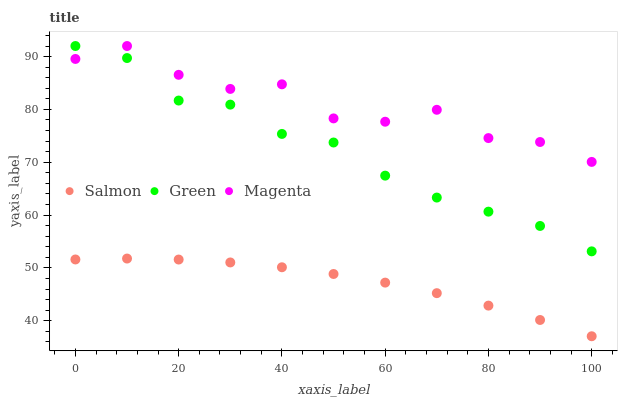Does Salmon have the minimum area under the curve?
Answer yes or no. Yes. Does Magenta have the maximum area under the curve?
Answer yes or no. Yes. Does Magenta have the minimum area under the curve?
Answer yes or no. No. Does Salmon have the maximum area under the curve?
Answer yes or no. No. Is Salmon the smoothest?
Answer yes or no. Yes. Is Magenta the roughest?
Answer yes or no. Yes. Is Magenta the smoothest?
Answer yes or no. No. Is Salmon the roughest?
Answer yes or no. No. Does Salmon have the lowest value?
Answer yes or no. Yes. Does Magenta have the lowest value?
Answer yes or no. No. Does Green have the highest value?
Answer yes or no. Yes. Does Magenta have the highest value?
Answer yes or no. No. Is Salmon less than Magenta?
Answer yes or no. Yes. Is Green greater than Salmon?
Answer yes or no. Yes. Does Green intersect Magenta?
Answer yes or no. Yes. Is Green less than Magenta?
Answer yes or no. No. Is Green greater than Magenta?
Answer yes or no. No. Does Salmon intersect Magenta?
Answer yes or no. No. 